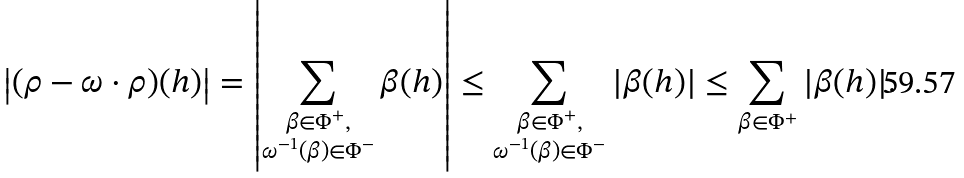Convert formula to latex. <formula><loc_0><loc_0><loc_500><loc_500>\left | ( \rho - \omega \cdot \rho ) ( h ) \right | = \left | \sum _ { \substack { \beta \in \Phi ^ { + } , \\ \omega ^ { - 1 } ( \beta ) \in \Phi ^ { - } } } \beta ( h ) \right | \leq \sum _ { \substack { \beta \in \Phi ^ { + } , \\ \omega ^ { - 1 } ( \beta ) \in \Phi ^ { - } } } | \beta ( h ) | \leq \sum _ { \beta \in \Phi ^ { + } } | \beta ( h ) | .</formula> 